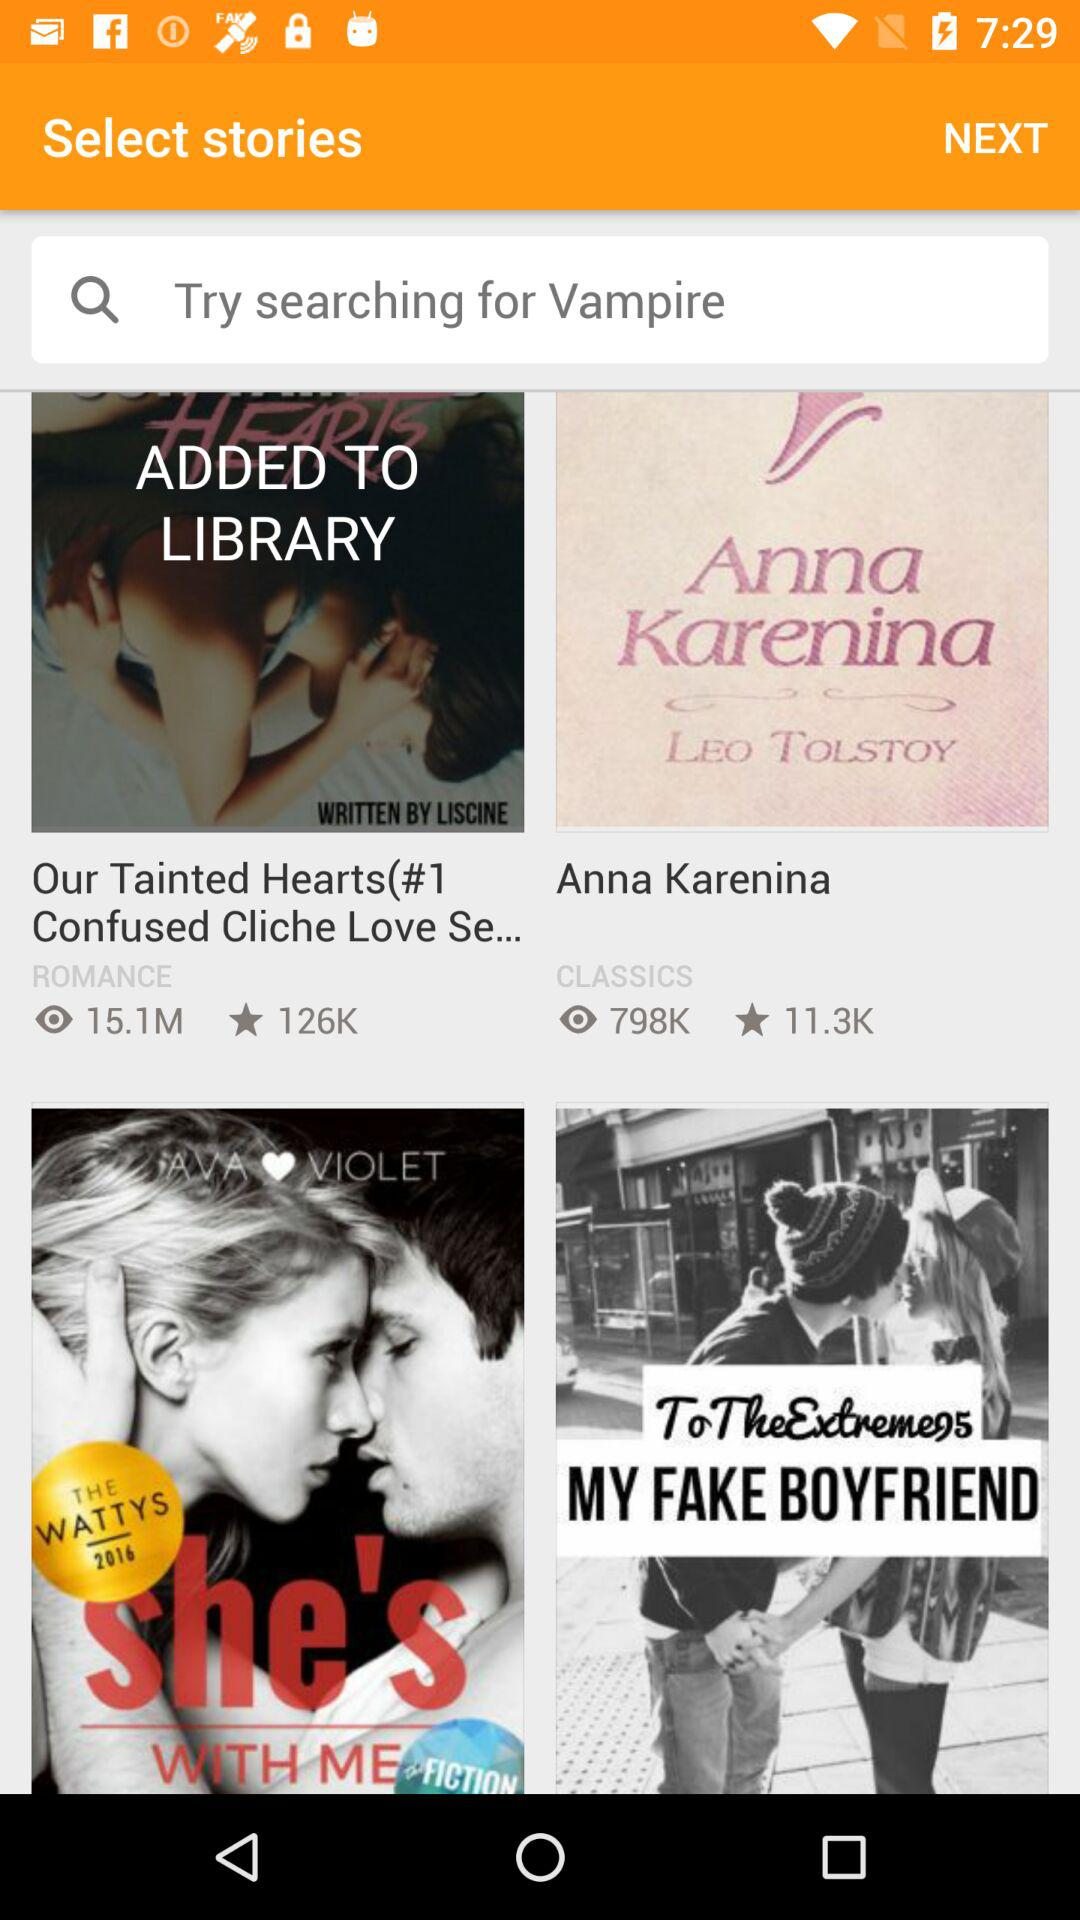How many people viewed "Our Tainted Hearts(#1 Confused Cliche Love Se..."? It is viewed by 15.1 million people. 